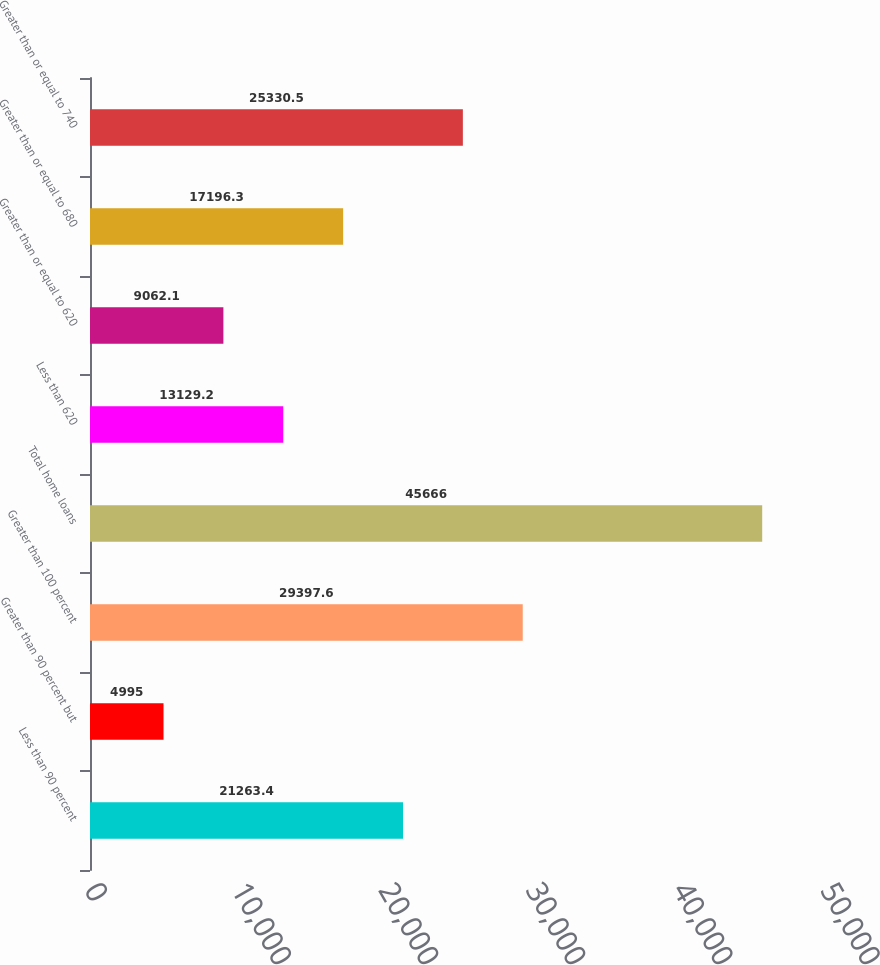Convert chart. <chart><loc_0><loc_0><loc_500><loc_500><bar_chart><fcel>Less than 90 percent<fcel>Greater than 90 percent but<fcel>Greater than 100 percent<fcel>Total home loans<fcel>Less than 620<fcel>Greater than or equal to 620<fcel>Greater than or equal to 680<fcel>Greater than or equal to 740<nl><fcel>21263.4<fcel>4995<fcel>29397.6<fcel>45666<fcel>13129.2<fcel>9062.1<fcel>17196.3<fcel>25330.5<nl></chart> 